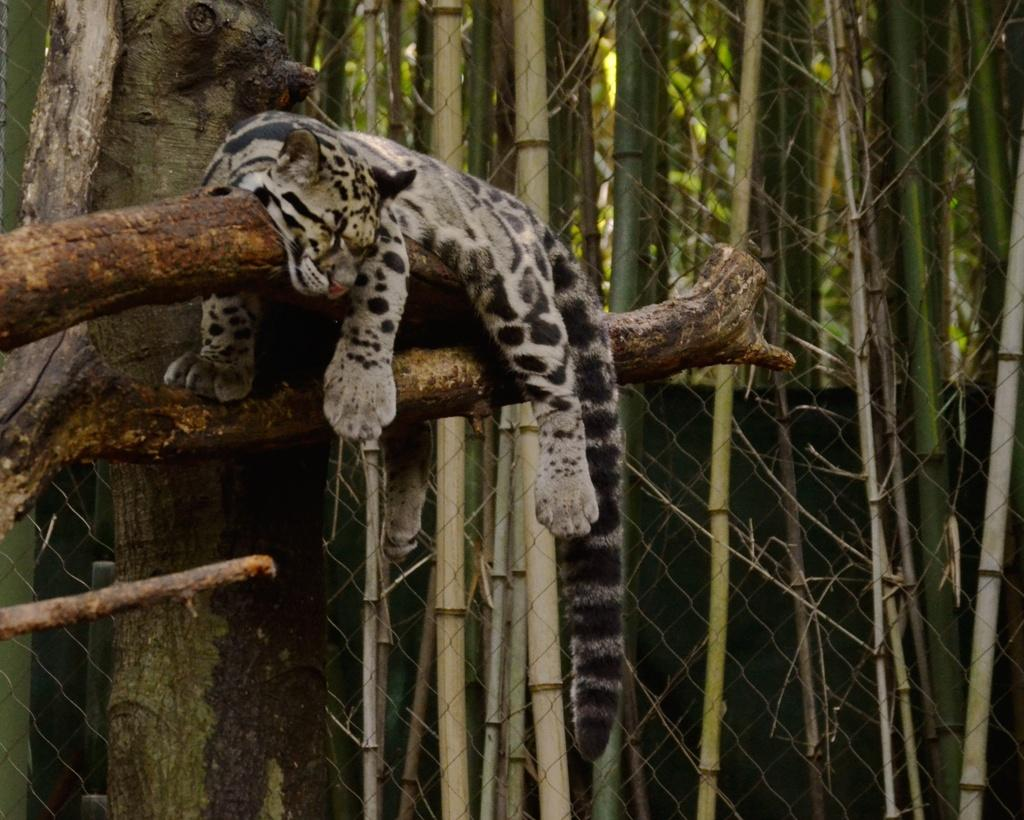What is the main subject in the foreground of the image? There is an animal on a branch of a tree in the foreground. What can be seen in the background of the image? There is a fence and bamboo trees in the background. Can you make any assumptions about the location of the image? The image may have been taken in a zoo, given the presence of an animal and a fence. What time of day was the image likely taken? The image was likely taken during the day, as the lighting appears bright. Can you tell me how many forks are in the drawer in the image? There are no forks or drawers present in the image. Is the animal swimming in the image? There is no indication that the animal is swimming in the image; it is sitting on a branch of a tree. 